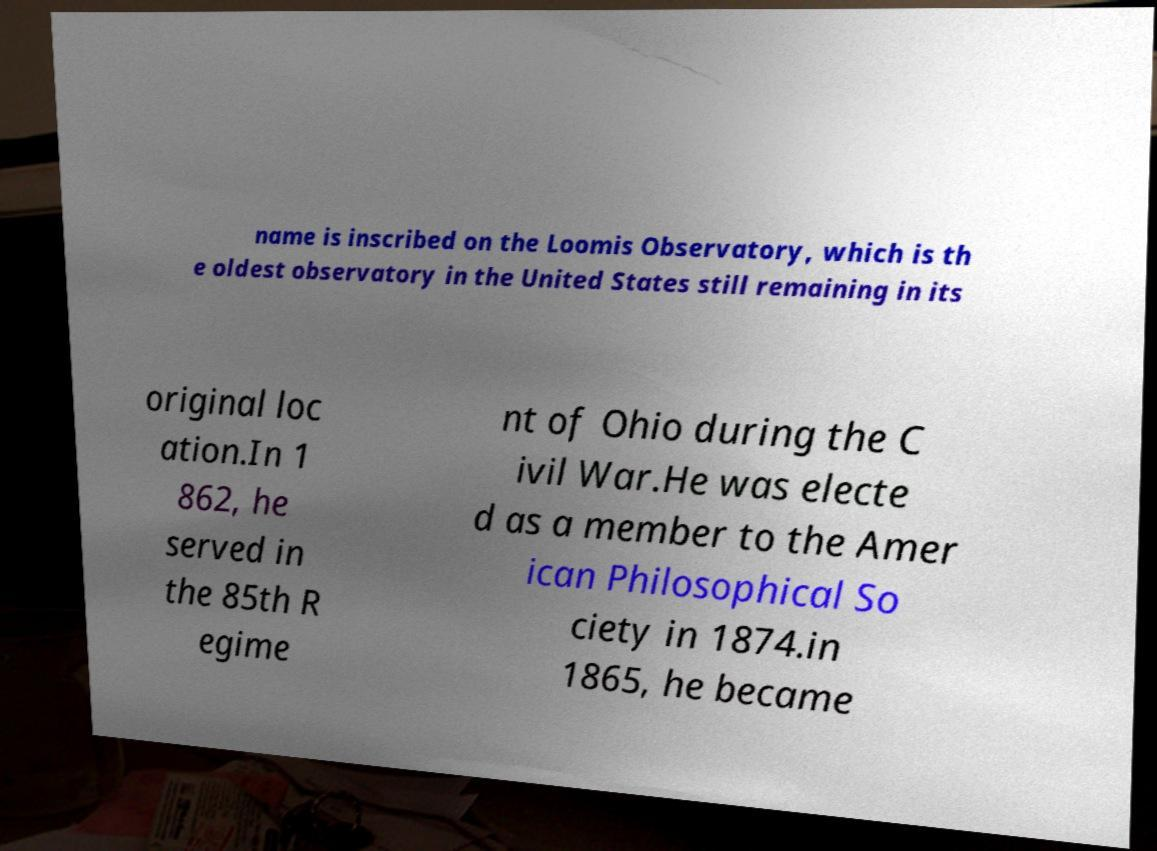Could you extract and type out the text from this image? name is inscribed on the Loomis Observatory, which is th e oldest observatory in the United States still remaining in its original loc ation.In 1 862, he served in the 85th R egime nt of Ohio during the C ivil War.He was electe d as a member to the Amer ican Philosophical So ciety in 1874.in 1865, he became 